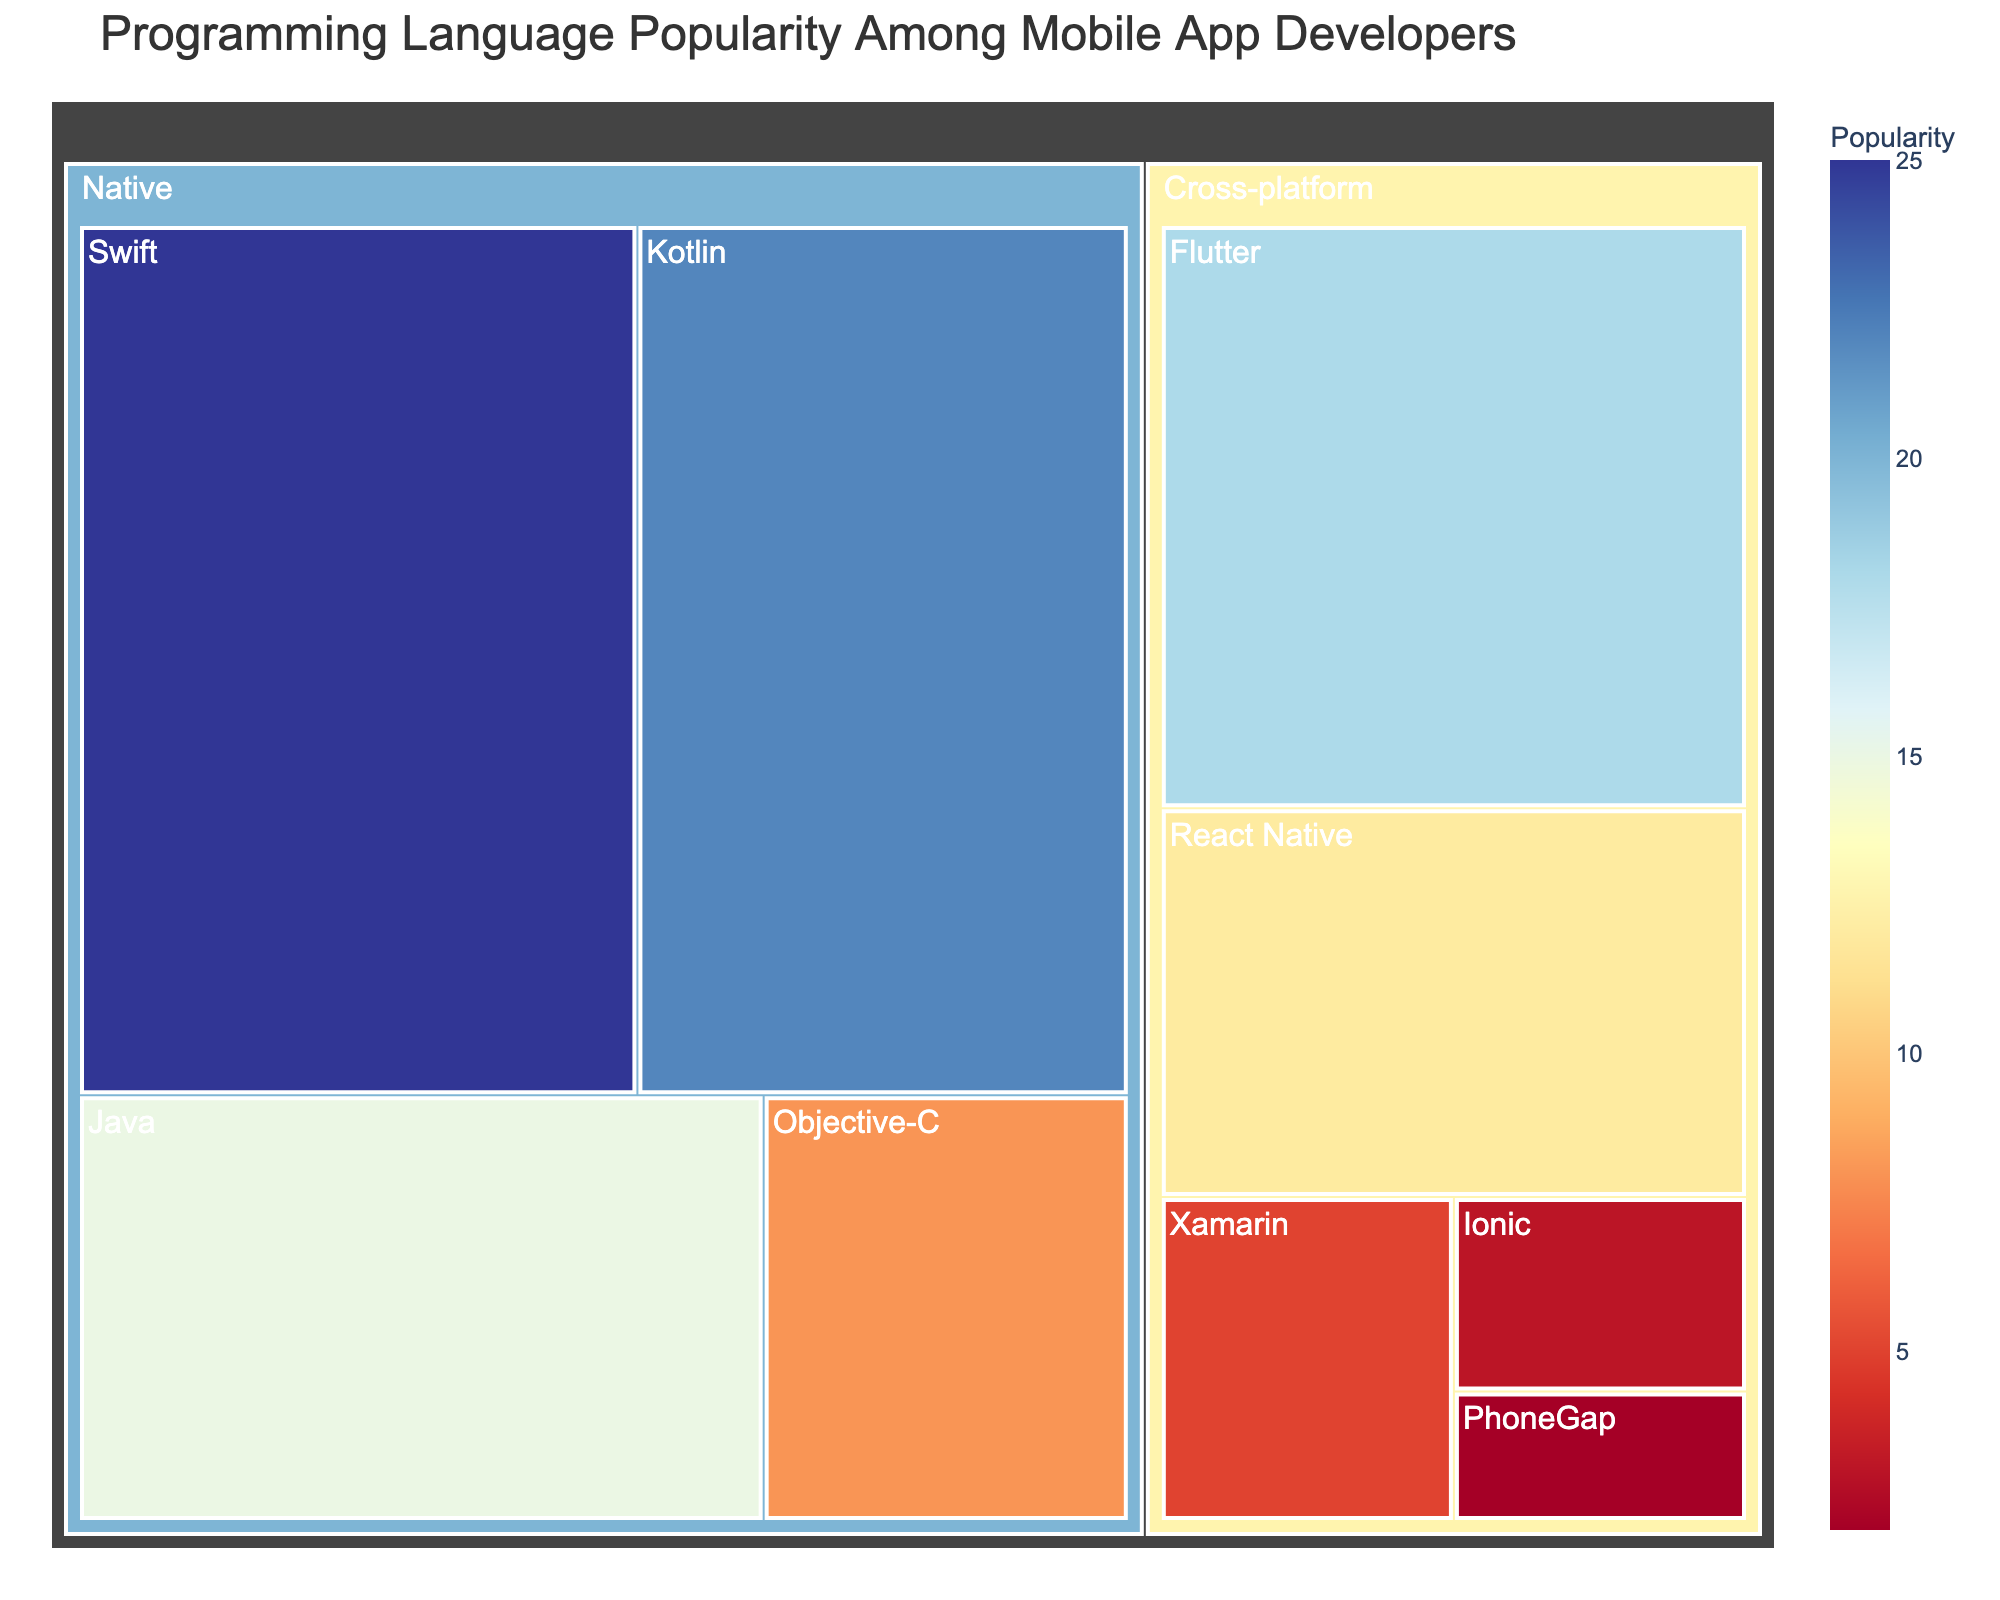what is the title of the treemap? The title is usually displayed at the top of the chart in a larger or bolder font. In this case, the title is "Programming Language Popularity Among Mobile App Developers."
Answer: Programming Language Popularity Among Mobile App Developers which category has the most subcategories? Each category in the treemap is divided into smaller sections representing subcategories. By scanning the sections, we see that the "Cross-platform" category has more subcategories compared to the "Native" category.
Answer: Cross-platform which subcategory has the highest value among Native frameworks? Among the "Native" category sections, we look at the values for each subcategory and note that "Swift" has the highest value at 25.
Answer: Swift how many more developers use Swift compared to Kotlin? To find the difference, subtract the value of "Kotlin" from the value of "Swift" (25 - 22). The result is 3.
Answer: 3 which subcategory under Cross-platform is the least popular? In the "Cross-platform" category, the smallest section with the lowest value is "PhoneGap" with a value of 2.
Answer: PhoneGap what is the sum of all the values for Cross-platform frameworks? Add up the values for each subcategory within the "Cross-platform" category: 18 (Flutter) + 12 (React Native) + 5 (Xamarin) + 3 (Ionic) + 2 (PhoneGap). The total is 40.
Answer: 40 how does the popularity of Java compare to React Native? We compare the values of "Java" under "Native" (15) and "React Native" under "Cross-platform" (12). Java is more popular as its value is greater.
Answer: Java is more popular what is the combined value of Swift and Flutter? To find the combined value, add their values: Swift (25) + Flutter (18). The result is 43.
Answer: 43 what percentage of the Cross-platform category's total value does React Native represent? React Native has a value of 12. The total for the Cross-platform category is 40. To find the percentage, use (12 / 40) * 100. The percentage is 30%.
Answer: 30% which category has a higher total value and by how much? Sum the values for each category. Native: 25 (Swift) + 22 (Kotlin) + 8 (Objective-C) + 15 (Java) = 70. Cross-platform: 18 (Flutter) + 12 (React Native) + 5 (Xamarin) + 3 (Ionic) + 2 (PhoneGap) = 40. Native has a higher total value by 30 (70 - 40).
Answer: Native, by 30 